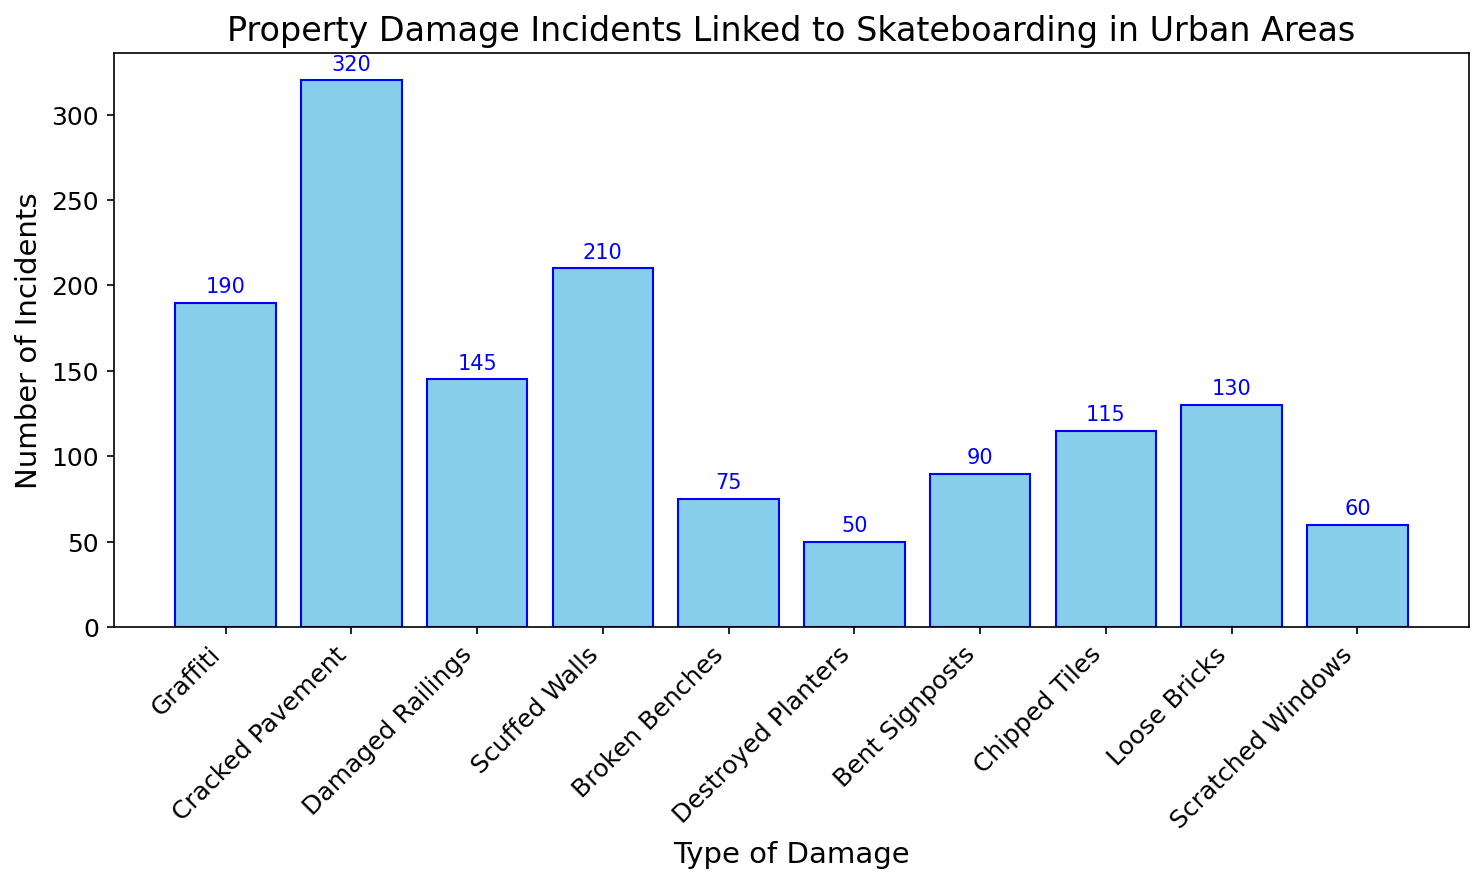What's the most common type of property damage linked to skateboarding? The bar representing "Cracked Pavement" is the tallest among all, indicating it has the most incidents.
Answer: Cracked Pavement What's the total number of incidents for Graffiti, Scuffed Walls, and Scratched Windows combined? Sum the number of incidents for Graffiti (190), Scuffed Walls (210), and Scratched Windows (60). The total is 190 + 210 + 60 = 460.
Answer: 460 Which type of damage has the lowest number of incidents? The bar representing "Destroyed Planters" is the shortest among all, indicating it has the fewest incidents.
Answer: Destroyed Planters How many more incidents of Cracked Pavement are there compared to Broken Benches? The number of incidents for Cracked Pavement is 320, and for Broken Benches is 75. The difference is 320 - 75 = 245.
Answer: 245 What is the difference in the number of incidents between Damaged Railings and Bent Signposts? The number of incidents for Damaged Railings is 145, and for Bent Signposts is 90. The difference is 145 - 90 = 55.
Answer: 55 Which type of damage has an incident count closest to 100? The number of incidents for Bent Signposts is 90 and for Chipped Tiles is 115. Bent Signposts are closest to 100.
Answer: Bent Signposts How many types of damage have more than 200 incidents? By observing the heights of the bars, it is clear that Cracked Pavement (320) and Scuffed Walls (210) are the types of damage with more than 200 incidents.
Answer: 2 What is the median number of incidents for all types of damage? Arrange the incident counts in ascending order: 50, 60, 75, 90, 115, 130, 145, 190, 210, 320. The median will be the average of the 5th and 6th values: (115 + 130) / 2 = 122.5.
Answer: 122.5 